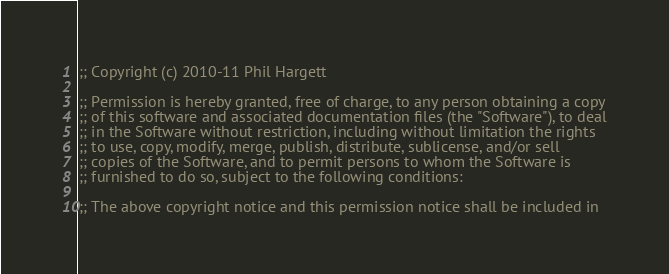<code> <loc_0><loc_0><loc_500><loc_500><_Lisp_>;; Copyright (c) 2010-11 Phil Hargett

;; Permission is hereby granted, free of charge, to any person obtaining a copy
;; of this software and associated documentation files (the "Software"), to deal
;; in the Software without restriction, including without limitation the rights
;; to use, copy, modify, merge, publish, distribute, sublicense, and/or sell
;; copies of the Software, and to permit persons to whom the Software is
;; furnished to do so, subject to the following conditions:

;; The above copyright notice and this permission notice shall be included in</code> 